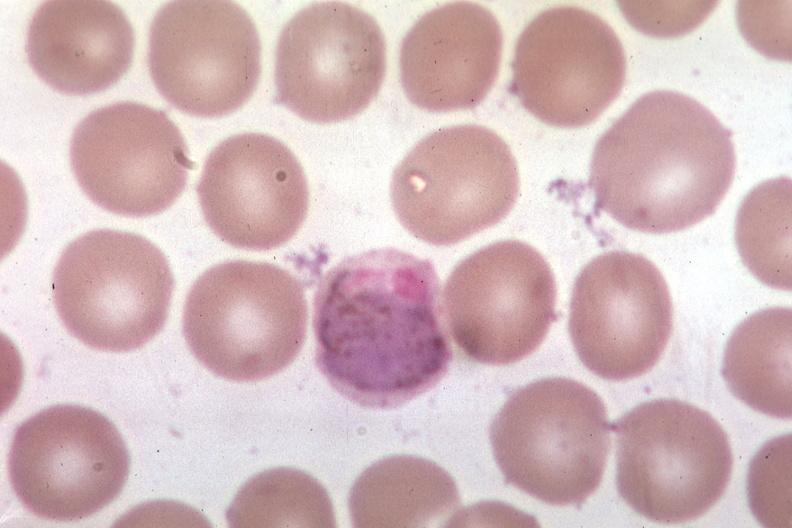s malaria plasmodium vivax present?
Answer the question using a single word or phrase. Yes 